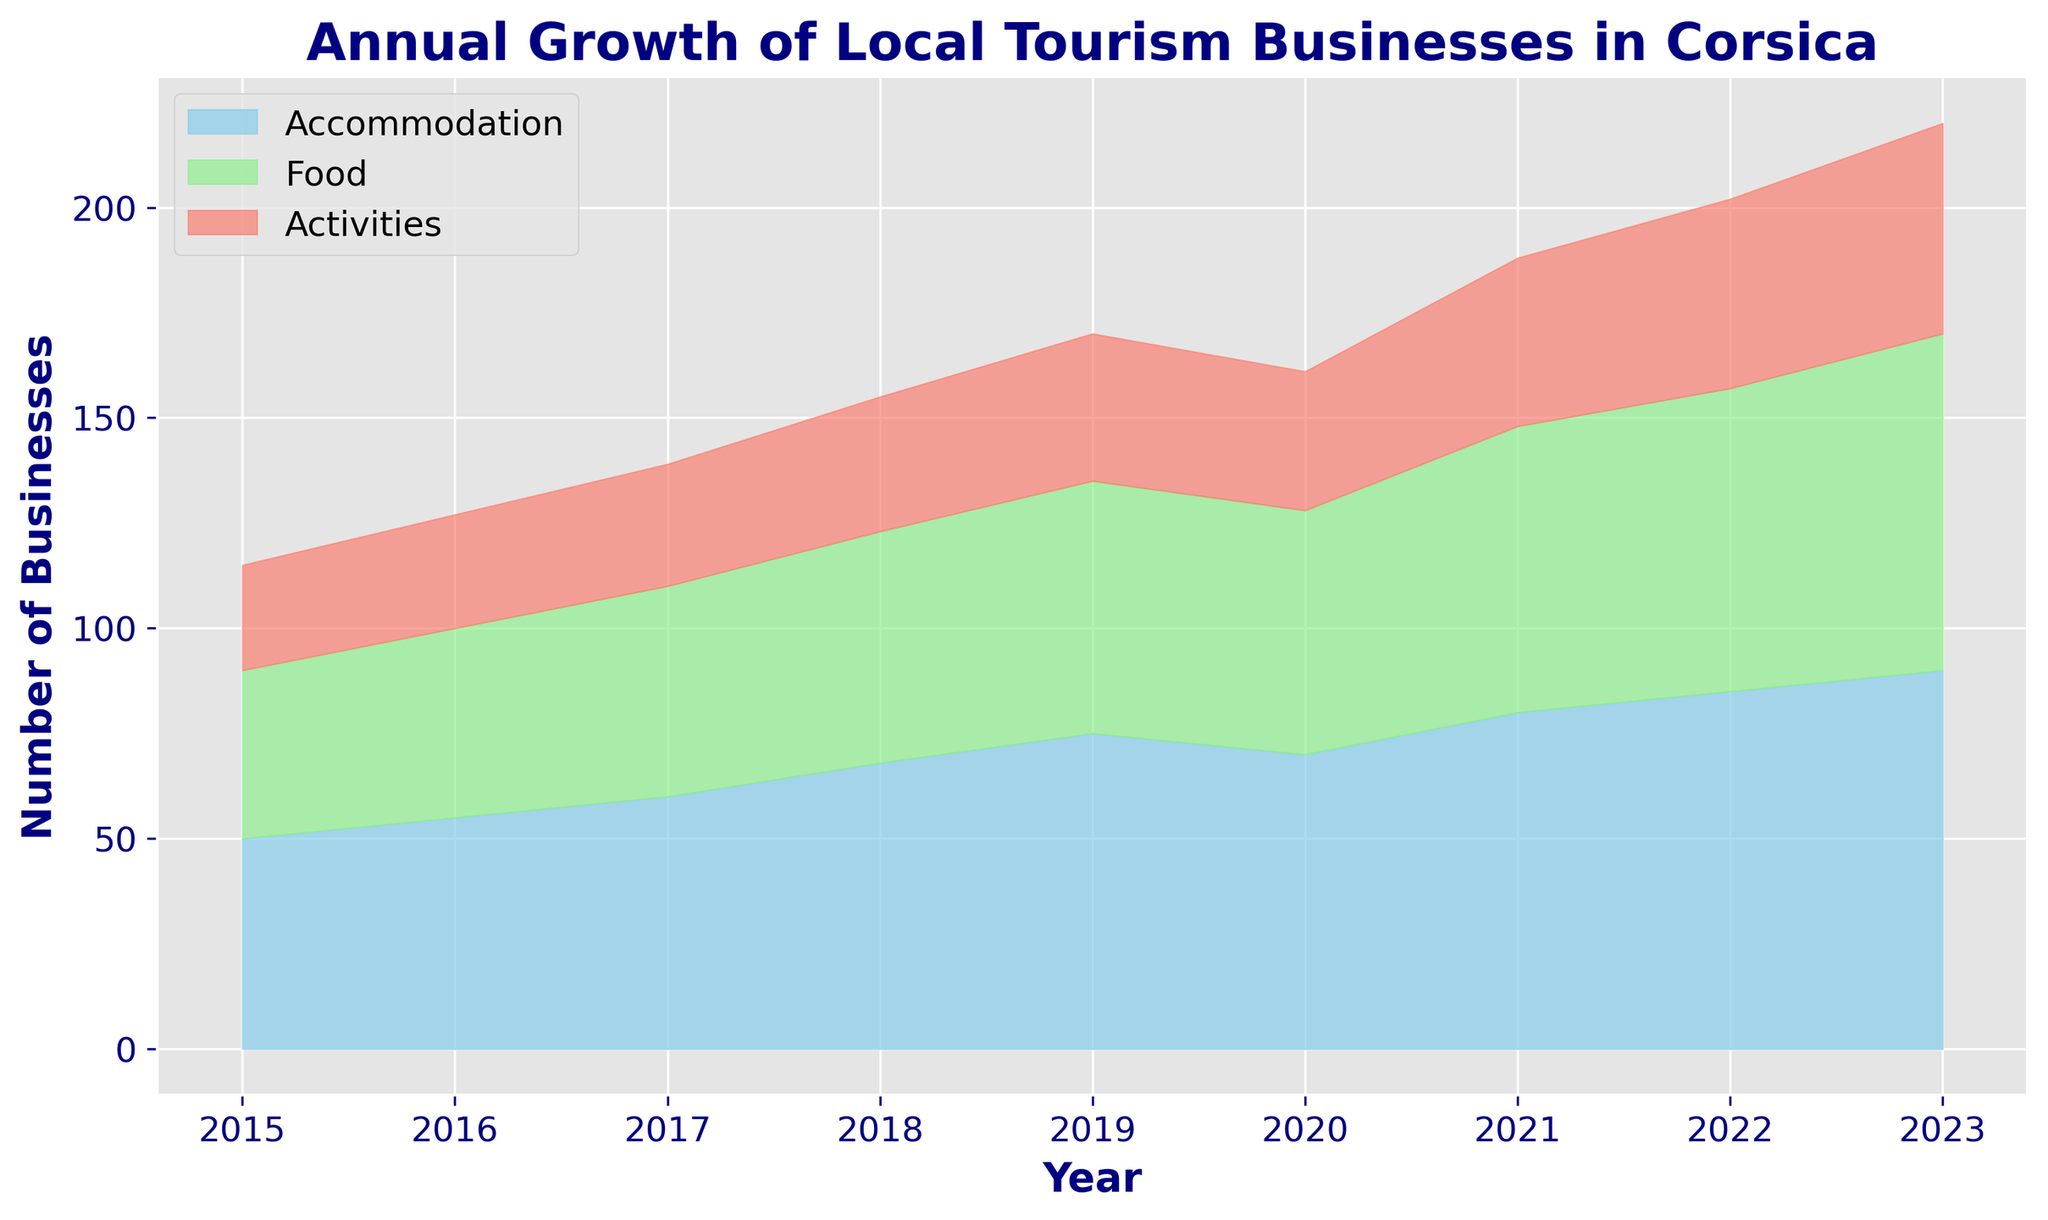What was the overall trend for Accommodation businesses from 2015 to 2023? To find the trend, observe the blue area representing Accommodation on the chart. From 2015 to 2023, it consistently increases each year, rising from around 50 to 90.
Answer: Increasing Which type of business experienced the most significant growth from 2020 to 2023? To determine this, compare the increase in the height of each color band: Accommodation (90-70=20), Food (80-58=22), and Activities (50-33=17). Food grew the most.
Answer: Food How did the number of Food businesses change from 2019 to 2020? Look at the green area representing Food between 2019 and 2020. It decreases slightly from 60 to 58.
Answer: Decreased Which type of business had the smallest growth in total number from 2015 to 2023? Calculate the difference in numbers for each category: Accommodation (90-50=40), Food (80-40=40), Activities (50-25=25). Activities had the smallest growth.
Answer: Activities In which year did Activities businesses reach 40? The salmon area representing Activities first reaches 40 in 2021.
Answer: 2021 Which two years showed a decrease in the number of Accommodation businesses? Look at the blue area representing Accommodation. It drops from 75 to 70 between 2019 and 2020. That's the only decrease in Accommodation.
Answer: 2019 to 2020 What is the total number of businesses across all types in 2018? Sum the heights for each type in 2018: Accommodation (68), Food (55), Activities (32). Total = 68 + 55 + 32 = 155.
Answer: 155 How did the relative proportions of Food and Activities businesses change from 2015 to 2023? In 2015, the green and salmon areas are approximately 40 and 25, while in 2023 they are around 80 and 50. While both have doubled, Food grown slightly more relative to its initial number.
Answer: Both increased proportionally, but Food grew slightly more relatively Which type of business had the highest number in any given year throughout the period? Look at the highest points reached by each color band. Accommodation reached the highest number of 90 in 2023.
Answer: Accommodation 